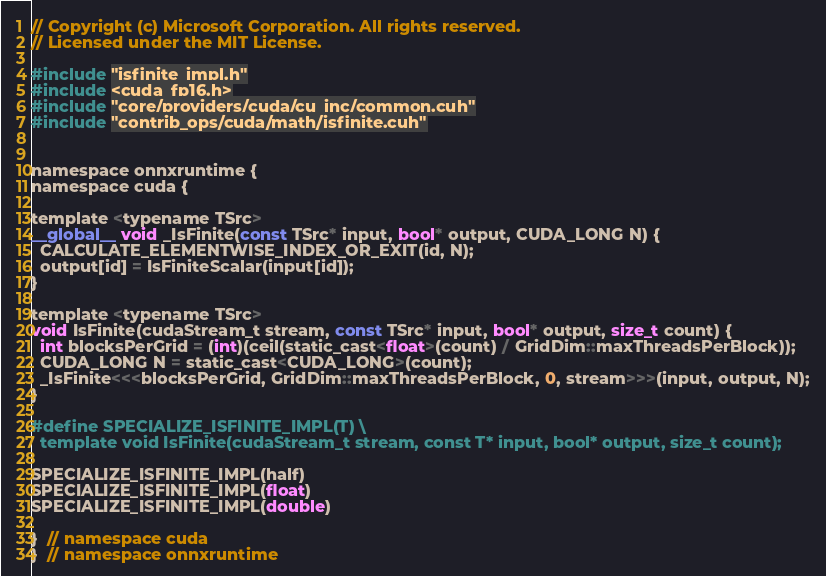<code> <loc_0><loc_0><loc_500><loc_500><_Cuda_>// Copyright (c) Microsoft Corporation. All rights reserved.
// Licensed under the MIT License.

#include "isfinite_impl.h"
#include <cuda_fp16.h>
#include "core/providers/cuda/cu_inc/common.cuh"
#include "contrib_ops/cuda/math/isfinite.cuh"


namespace onnxruntime {
namespace cuda {

template <typename TSrc>
__global__ void _IsFinite(const TSrc* input, bool* output, CUDA_LONG N) {
  CALCULATE_ELEMENTWISE_INDEX_OR_EXIT(id, N);
  output[id] = IsFiniteScalar(input[id]);
}

template <typename TSrc>
void IsFinite(cudaStream_t stream, const TSrc* input, bool* output, size_t count) {
  int blocksPerGrid = (int)(ceil(static_cast<float>(count) / GridDim::maxThreadsPerBlock));
  CUDA_LONG N = static_cast<CUDA_LONG>(count);
  _IsFinite<<<blocksPerGrid, GridDim::maxThreadsPerBlock, 0, stream>>>(input, output, N);
}

#define SPECIALIZE_ISFINITE_IMPL(T) \
  template void IsFinite(cudaStream_t stream, const T* input, bool* output, size_t count);

SPECIALIZE_ISFINITE_IMPL(half)
SPECIALIZE_ISFINITE_IMPL(float)
SPECIALIZE_ISFINITE_IMPL(double)

}  // namespace cuda
}  // namespace onnxruntime</code> 